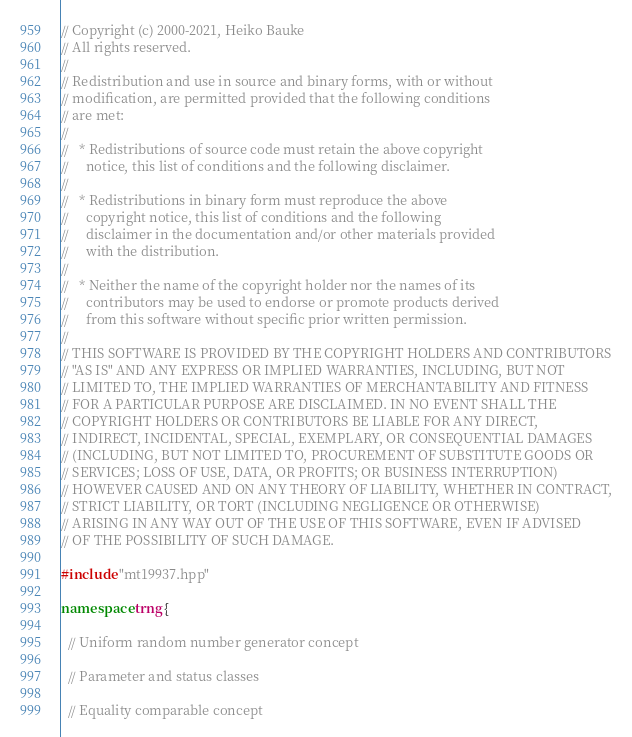Convert code to text. <code><loc_0><loc_0><loc_500><loc_500><_C++_>// Copyright (c) 2000-2021, Heiko Bauke
// All rights reserved.
//
// Redistribution and use in source and binary forms, with or without
// modification, are permitted provided that the following conditions
// are met:
//
//   * Redistributions of source code must retain the above copyright
//     notice, this list of conditions and the following disclaimer.
//
//   * Redistributions in binary form must reproduce the above
//     copyright notice, this list of conditions and the following
//     disclaimer in the documentation and/or other materials provided
//     with the distribution.
//
//   * Neither the name of the copyright holder nor the names of its
//     contributors may be used to endorse or promote products derived
//     from this software without specific prior written permission.
//
// THIS SOFTWARE IS PROVIDED BY THE COPYRIGHT HOLDERS AND CONTRIBUTORS
// "AS IS" AND ANY EXPRESS OR IMPLIED WARRANTIES, INCLUDING, BUT NOT
// LIMITED TO, THE IMPLIED WARRANTIES OF MERCHANTABILITY AND FITNESS
// FOR A PARTICULAR PURPOSE ARE DISCLAIMED. IN NO EVENT SHALL THE
// COPYRIGHT HOLDERS OR CONTRIBUTORS BE LIABLE FOR ANY DIRECT,
// INDIRECT, INCIDENTAL, SPECIAL, EXEMPLARY, OR CONSEQUENTIAL DAMAGES
// (INCLUDING, BUT NOT LIMITED TO, PROCUREMENT OF SUBSTITUTE GOODS OR
// SERVICES; LOSS OF USE, DATA, OR PROFITS; OR BUSINESS INTERRUPTION)
// HOWEVER CAUSED AND ON ANY THEORY OF LIABILITY, WHETHER IN CONTRACT,
// STRICT LIABILITY, OR TORT (INCLUDING NEGLIGENCE OR OTHERWISE)
// ARISING IN ANY WAY OUT OF THE USE OF THIS SOFTWARE, EVEN IF ADVISED
// OF THE POSSIBILITY OF SUCH DAMAGE.

#include "mt19937.hpp"

namespace trng {

  // Uniform random number generator concept

  // Parameter and status classes

  // Equality comparable concept</code> 